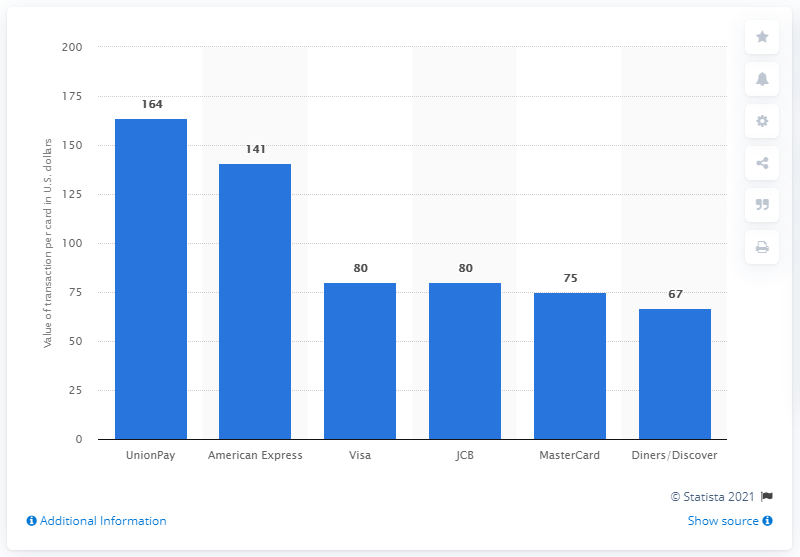Indicate a few pertinent items in this graphic. In 2016, the average transaction amount on UnionPay credit cards was approximately CNY 164. 